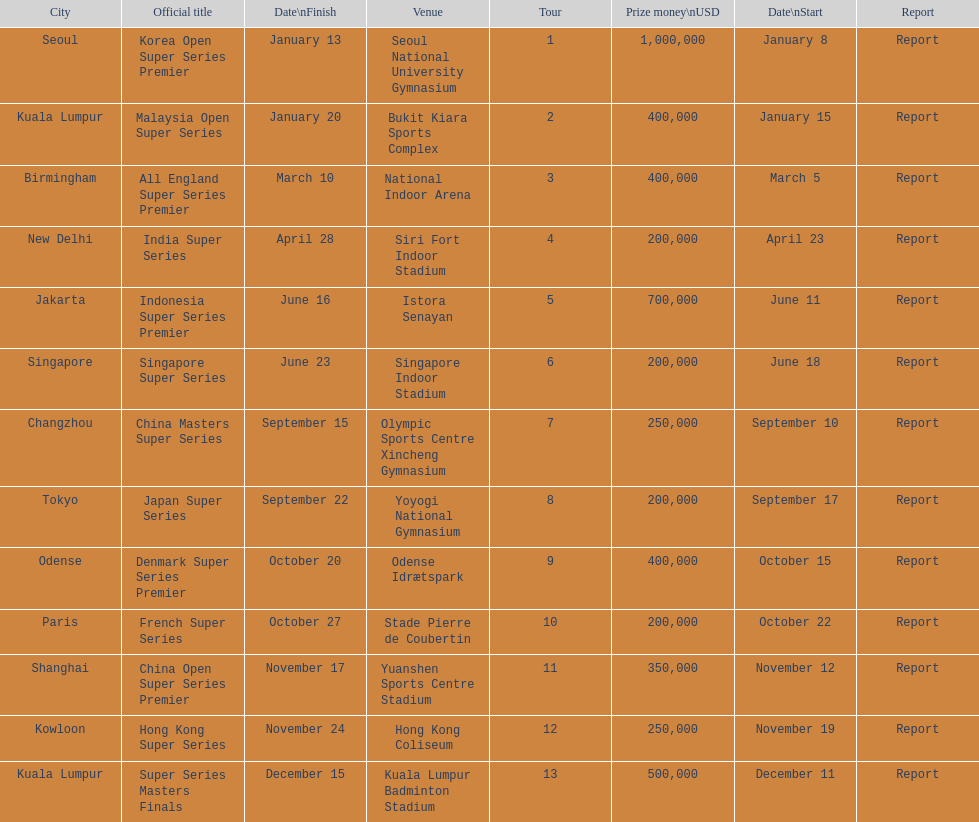Help me parse the entirety of this table. {'header': ['City', 'Official title', 'Date\\nFinish', 'Venue', 'Tour', 'Prize money\\nUSD', 'Date\\nStart', 'Report'], 'rows': [['Seoul', 'Korea Open Super Series Premier', 'January 13', 'Seoul National University Gymnasium', '1', '1,000,000', 'January 8', 'Report'], ['Kuala Lumpur', 'Malaysia Open Super Series', 'January 20', 'Bukit Kiara Sports Complex', '2', '400,000', 'January 15', 'Report'], ['Birmingham', 'All England Super Series Premier', 'March 10', 'National Indoor Arena', '3', '400,000', 'March 5', 'Report'], ['New Delhi', 'India Super Series', 'April 28', 'Siri Fort Indoor Stadium', '4', '200,000', 'April 23', 'Report'], ['Jakarta', 'Indonesia Super Series Premier', 'June 16', 'Istora Senayan', '5', '700,000', 'June 11', 'Report'], ['Singapore', 'Singapore Super Series', 'June 23', 'Singapore Indoor Stadium', '6', '200,000', 'June 18', 'Report'], ['Changzhou', 'China Masters Super Series', 'September 15', 'Olympic Sports Centre Xincheng Gymnasium', '7', '250,000', 'September 10', 'Report'], ['Tokyo', 'Japan Super Series', 'September 22', 'Yoyogi National Gymnasium', '8', '200,000', 'September 17', 'Report'], ['Odense', 'Denmark Super Series Premier', 'October 20', 'Odense Idrætspark', '9', '400,000', 'October 15', 'Report'], ['Paris', 'French Super Series', 'October 27', 'Stade Pierre de Coubertin', '10', '200,000', 'October 22', 'Report'], ['Shanghai', 'China Open Super Series Premier', 'November 17', 'Yuanshen Sports Centre Stadium', '11', '350,000', 'November 12', 'Report'], ['Kowloon', 'Hong Kong Super Series', 'November 24', 'Hong Kong Coliseum', '12', '250,000', 'November 19', 'Report'], ['Kuala Lumpur', 'Super Series Masters Finals', 'December 15', 'Kuala Lumpur Badminton Stadium', '13', '500,000', 'December 11', 'Report']]} Does the malaysia open super series pay more or less than french super series? More. 